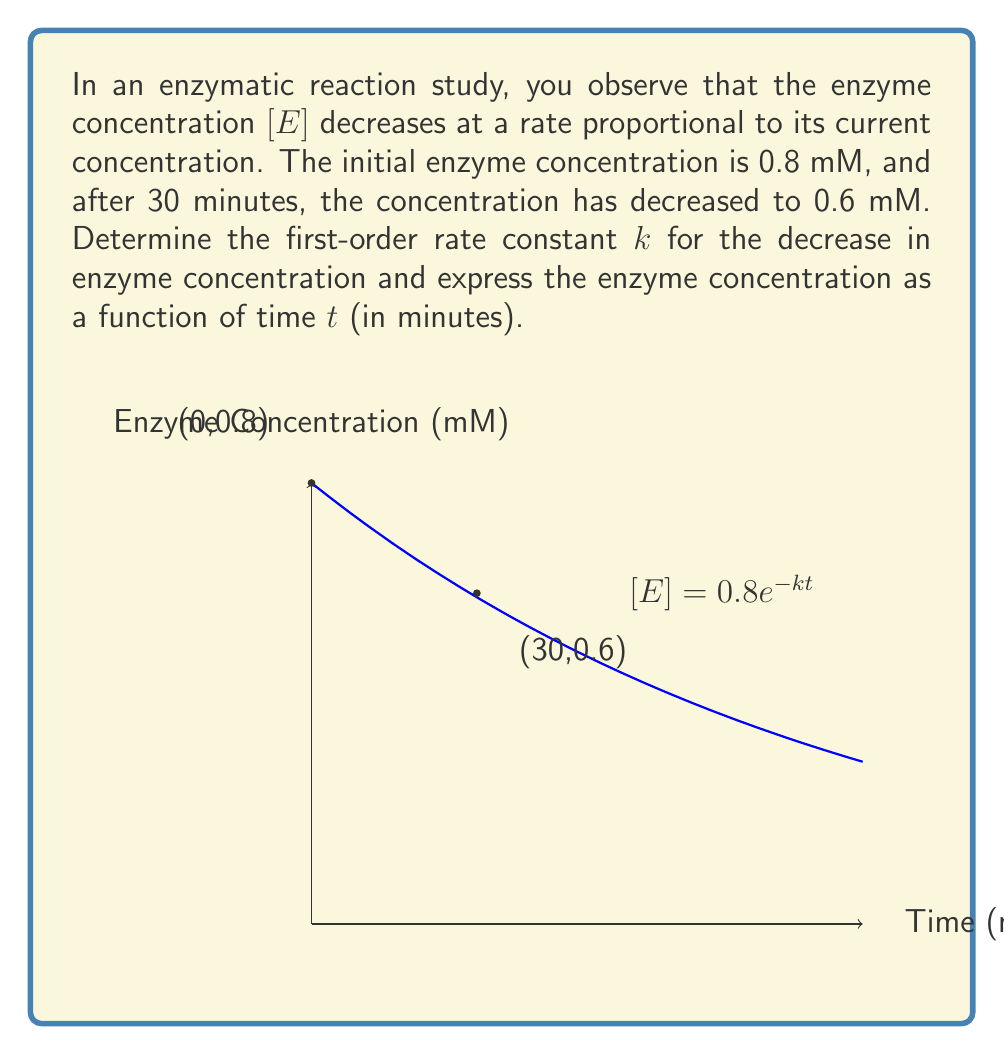Show me your answer to this math problem. 1) The first-order differential equation describing the rate of change in enzyme concentration is:

   $$\frac{d[E]}{dt} = -k[E]$$

2) The solution to this equation is:

   $$[E] = [E]_0e^{-kt}$$

   where $[E]_0$ is the initial enzyme concentration.

3) We know that $[E]_0 = 0.8$ mM and at $t = 30$ minutes, $[E] = 0.6$ mM. Let's substitute these values:

   $$0.6 = 0.8e^{-k(30)}$$

4) Divide both sides by 0.8:

   $$0.75 = e^{-30k}$$

5) Take the natural logarithm of both sides:

   $$\ln(0.75) = -30k$$

6) Solve for $k$:

   $$k = -\frac{\ln(0.75)}{30} \approx 0.00963 \text{ min}^{-1}$$

7) Now that we have $k$, we can express $[E]$ as a function of time:

   $$[E] = 0.8e^{-0.00963t}$$

   where $t$ is in minutes and $[E]$ is in mM.
Answer: $k \approx 0.00963 \text{ min}^{-1}$; $[E] = 0.8e^{-0.00963t}$ mM 